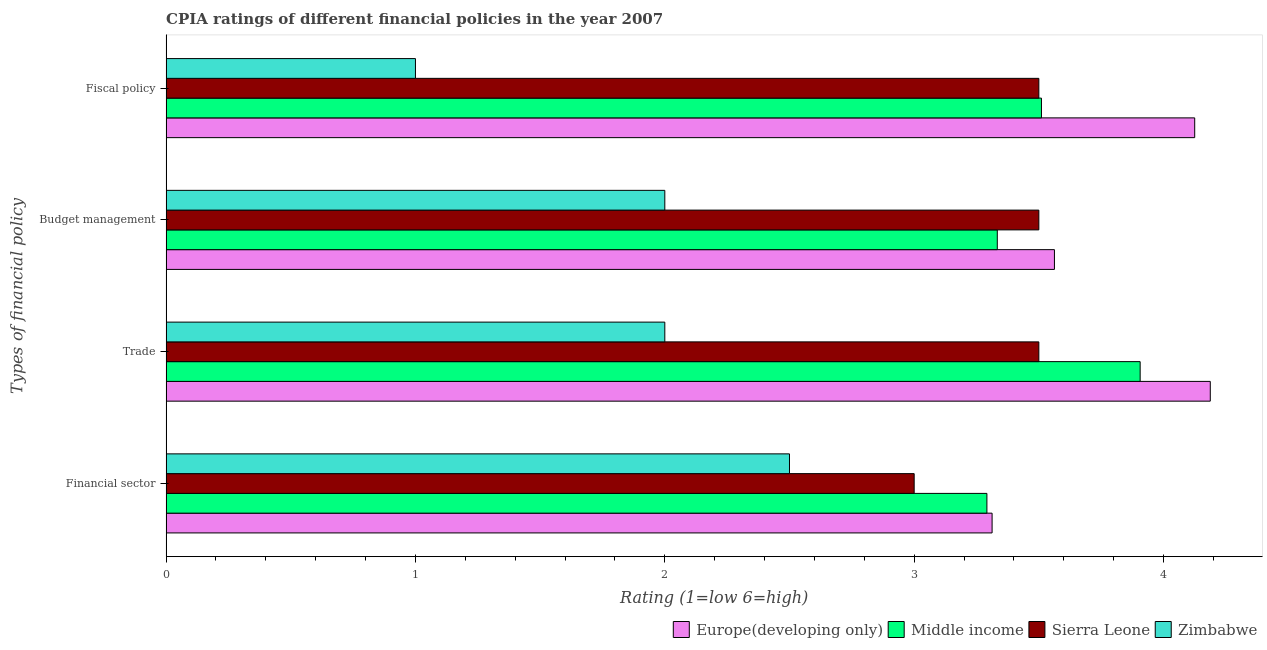Are the number of bars per tick equal to the number of legend labels?
Offer a very short reply. Yes. Are the number of bars on each tick of the Y-axis equal?
Your answer should be very brief. Yes. How many bars are there on the 3rd tick from the top?
Ensure brevity in your answer.  4. What is the label of the 3rd group of bars from the top?
Give a very brief answer. Trade. What is the cpia rating of financial sector in Sierra Leone?
Your answer should be compact. 3. Across all countries, what is the maximum cpia rating of budget management?
Provide a short and direct response. 3.56. In which country was the cpia rating of financial sector maximum?
Keep it short and to the point. Europe(developing only). In which country was the cpia rating of financial sector minimum?
Keep it short and to the point. Zimbabwe. What is the total cpia rating of trade in the graph?
Provide a succinct answer. 13.59. What is the difference between the cpia rating of trade in Europe(developing only) and that in Sierra Leone?
Provide a short and direct response. 0.69. What is the difference between the cpia rating of trade in Sierra Leone and the cpia rating of financial sector in Europe(developing only)?
Offer a very short reply. 0.19. What is the average cpia rating of budget management per country?
Your answer should be very brief. 3.1. What is the ratio of the cpia rating of budget management in Zimbabwe to that in Europe(developing only)?
Keep it short and to the point. 0.56. Is the cpia rating of fiscal policy in Middle income less than that in Zimbabwe?
Your answer should be very brief. No. What is the difference between the highest and the second highest cpia rating of financial sector?
Provide a short and direct response. 0.02. What is the difference between the highest and the lowest cpia rating of financial sector?
Offer a terse response. 0.81. In how many countries, is the cpia rating of financial sector greater than the average cpia rating of financial sector taken over all countries?
Keep it short and to the point. 2. Is the sum of the cpia rating of trade in Middle income and Europe(developing only) greater than the maximum cpia rating of financial sector across all countries?
Give a very brief answer. Yes. Is it the case that in every country, the sum of the cpia rating of fiscal policy and cpia rating of trade is greater than the sum of cpia rating of budget management and cpia rating of financial sector?
Your response must be concise. No. What does the 1st bar from the top in Fiscal policy represents?
Keep it short and to the point. Zimbabwe. What does the 2nd bar from the bottom in Fiscal policy represents?
Your answer should be compact. Middle income. Is it the case that in every country, the sum of the cpia rating of financial sector and cpia rating of trade is greater than the cpia rating of budget management?
Provide a short and direct response. Yes. Are all the bars in the graph horizontal?
Ensure brevity in your answer.  Yes. How many countries are there in the graph?
Offer a terse response. 4. What is the difference between two consecutive major ticks on the X-axis?
Your answer should be compact. 1. Does the graph contain any zero values?
Your answer should be very brief. No. How many legend labels are there?
Give a very brief answer. 4. How are the legend labels stacked?
Provide a short and direct response. Horizontal. What is the title of the graph?
Your answer should be very brief. CPIA ratings of different financial policies in the year 2007. What is the label or title of the X-axis?
Keep it short and to the point. Rating (1=low 6=high). What is the label or title of the Y-axis?
Provide a succinct answer. Types of financial policy. What is the Rating (1=low 6=high) of Europe(developing only) in Financial sector?
Give a very brief answer. 3.31. What is the Rating (1=low 6=high) in Middle income in Financial sector?
Your answer should be compact. 3.29. What is the Rating (1=low 6=high) in Europe(developing only) in Trade?
Give a very brief answer. 4.19. What is the Rating (1=low 6=high) of Middle income in Trade?
Offer a terse response. 3.91. What is the Rating (1=low 6=high) in Sierra Leone in Trade?
Your answer should be very brief. 3.5. What is the Rating (1=low 6=high) in Zimbabwe in Trade?
Your answer should be very brief. 2. What is the Rating (1=low 6=high) in Europe(developing only) in Budget management?
Provide a short and direct response. 3.56. What is the Rating (1=low 6=high) in Middle income in Budget management?
Keep it short and to the point. 3.33. What is the Rating (1=low 6=high) in Zimbabwe in Budget management?
Give a very brief answer. 2. What is the Rating (1=low 6=high) in Europe(developing only) in Fiscal policy?
Offer a terse response. 4.12. What is the Rating (1=low 6=high) in Middle income in Fiscal policy?
Keep it short and to the point. 3.51. What is the Rating (1=low 6=high) in Sierra Leone in Fiscal policy?
Give a very brief answer. 3.5. Across all Types of financial policy, what is the maximum Rating (1=low 6=high) in Europe(developing only)?
Your response must be concise. 4.19. Across all Types of financial policy, what is the maximum Rating (1=low 6=high) of Middle income?
Your answer should be very brief. 3.91. Across all Types of financial policy, what is the maximum Rating (1=low 6=high) of Sierra Leone?
Your answer should be compact. 3.5. Across all Types of financial policy, what is the maximum Rating (1=low 6=high) in Zimbabwe?
Your response must be concise. 2.5. Across all Types of financial policy, what is the minimum Rating (1=low 6=high) of Europe(developing only)?
Keep it short and to the point. 3.31. Across all Types of financial policy, what is the minimum Rating (1=low 6=high) of Middle income?
Offer a terse response. 3.29. What is the total Rating (1=low 6=high) in Europe(developing only) in the graph?
Provide a succinct answer. 15.19. What is the total Rating (1=low 6=high) of Middle income in the graph?
Offer a terse response. 14.04. What is the total Rating (1=low 6=high) in Sierra Leone in the graph?
Provide a short and direct response. 13.5. What is the difference between the Rating (1=low 6=high) in Europe(developing only) in Financial sector and that in Trade?
Your response must be concise. -0.88. What is the difference between the Rating (1=low 6=high) in Middle income in Financial sector and that in Trade?
Provide a succinct answer. -0.61. What is the difference between the Rating (1=low 6=high) in Zimbabwe in Financial sector and that in Trade?
Offer a very short reply. 0.5. What is the difference between the Rating (1=low 6=high) of Middle income in Financial sector and that in Budget management?
Ensure brevity in your answer.  -0.04. What is the difference between the Rating (1=low 6=high) of Sierra Leone in Financial sector and that in Budget management?
Make the answer very short. -0.5. What is the difference between the Rating (1=low 6=high) of Europe(developing only) in Financial sector and that in Fiscal policy?
Your response must be concise. -0.81. What is the difference between the Rating (1=low 6=high) in Middle income in Financial sector and that in Fiscal policy?
Your response must be concise. -0.22. What is the difference between the Rating (1=low 6=high) of Zimbabwe in Financial sector and that in Fiscal policy?
Give a very brief answer. 1.5. What is the difference between the Rating (1=low 6=high) in Middle income in Trade and that in Budget management?
Keep it short and to the point. 0.57. What is the difference between the Rating (1=low 6=high) of Europe(developing only) in Trade and that in Fiscal policy?
Your response must be concise. 0.06. What is the difference between the Rating (1=low 6=high) of Middle income in Trade and that in Fiscal policy?
Give a very brief answer. 0.4. What is the difference between the Rating (1=low 6=high) in Europe(developing only) in Budget management and that in Fiscal policy?
Offer a very short reply. -0.56. What is the difference between the Rating (1=low 6=high) of Middle income in Budget management and that in Fiscal policy?
Offer a very short reply. -0.18. What is the difference between the Rating (1=low 6=high) in Sierra Leone in Budget management and that in Fiscal policy?
Your answer should be compact. 0. What is the difference between the Rating (1=low 6=high) in Europe(developing only) in Financial sector and the Rating (1=low 6=high) in Middle income in Trade?
Your answer should be very brief. -0.59. What is the difference between the Rating (1=low 6=high) in Europe(developing only) in Financial sector and the Rating (1=low 6=high) in Sierra Leone in Trade?
Provide a short and direct response. -0.19. What is the difference between the Rating (1=low 6=high) of Europe(developing only) in Financial sector and the Rating (1=low 6=high) of Zimbabwe in Trade?
Provide a succinct answer. 1.31. What is the difference between the Rating (1=low 6=high) in Middle income in Financial sector and the Rating (1=low 6=high) in Sierra Leone in Trade?
Ensure brevity in your answer.  -0.21. What is the difference between the Rating (1=low 6=high) in Middle income in Financial sector and the Rating (1=low 6=high) in Zimbabwe in Trade?
Make the answer very short. 1.29. What is the difference between the Rating (1=low 6=high) in Sierra Leone in Financial sector and the Rating (1=low 6=high) in Zimbabwe in Trade?
Your answer should be compact. 1. What is the difference between the Rating (1=low 6=high) in Europe(developing only) in Financial sector and the Rating (1=low 6=high) in Middle income in Budget management?
Keep it short and to the point. -0.02. What is the difference between the Rating (1=low 6=high) in Europe(developing only) in Financial sector and the Rating (1=low 6=high) in Sierra Leone in Budget management?
Give a very brief answer. -0.19. What is the difference between the Rating (1=low 6=high) in Europe(developing only) in Financial sector and the Rating (1=low 6=high) in Zimbabwe in Budget management?
Your answer should be very brief. 1.31. What is the difference between the Rating (1=low 6=high) of Middle income in Financial sector and the Rating (1=low 6=high) of Sierra Leone in Budget management?
Offer a terse response. -0.21. What is the difference between the Rating (1=low 6=high) in Middle income in Financial sector and the Rating (1=low 6=high) in Zimbabwe in Budget management?
Ensure brevity in your answer.  1.29. What is the difference between the Rating (1=low 6=high) in Europe(developing only) in Financial sector and the Rating (1=low 6=high) in Middle income in Fiscal policy?
Keep it short and to the point. -0.2. What is the difference between the Rating (1=low 6=high) of Europe(developing only) in Financial sector and the Rating (1=low 6=high) of Sierra Leone in Fiscal policy?
Give a very brief answer. -0.19. What is the difference between the Rating (1=low 6=high) of Europe(developing only) in Financial sector and the Rating (1=low 6=high) of Zimbabwe in Fiscal policy?
Your answer should be very brief. 2.31. What is the difference between the Rating (1=low 6=high) in Middle income in Financial sector and the Rating (1=low 6=high) in Sierra Leone in Fiscal policy?
Give a very brief answer. -0.21. What is the difference between the Rating (1=low 6=high) of Middle income in Financial sector and the Rating (1=low 6=high) of Zimbabwe in Fiscal policy?
Make the answer very short. 2.29. What is the difference between the Rating (1=low 6=high) in Europe(developing only) in Trade and the Rating (1=low 6=high) in Middle income in Budget management?
Make the answer very short. 0.85. What is the difference between the Rating (1=low 6=high) in Europe(developing only) in Trade and the Rating (1=low 6=high) in Sierra Leone in Budget management?
Your answer should be compact. 0.69. What is the difference between the Rating (1=low 6=high) of Europe(developing only) in Trade and the Rating (1=low 6=high) of Zimbabwe in Budget management?
Your response must be concise. 2.19. What is the difference between the Rating (1=low 6=high) in Middle income in Trade and the Rating (1=low 6=high) in Sierra Leone in Budget management?
Your response must be concise. 0.41. What is the difference between the Rating (1=low 6=high) of Middle income in Trade and the Rating (1=low 6=high) of Zimbabwe in Budget management?
Offer a terse response. 1.91. What is the difference between the Rating (1=low 6=high) of Europe(developing only) in Trade and the Rating (1=low 6=high) of Middle income in Fiscal policy?
Your answer should be compact. 0.68. What is the difference between the Rating (1=low 6=high) in Europe(developing only) in Trade and the Rating (1=low 6=high) in Sierra Leone in Fiscal policy?
Your answer should be compact. 0.69. What is the difference between the Rating (1=low 6=high) of Europe(developing only) in Trade and the Rating (1=low 6=high) of Zimbabwe in Fiscal policy?
Your answer should be very brief. 3.19. What is the difference between the Rating (1=low 6=high) of Middle income in Trade and the Rating (1=low 6=high) of Sierra Leone in Fiscal policy?
Offer a very short reply. 0.41. What is the difference between the Rating (1=low 6=high) of Middle income in Trade and the Rating (1=low 6=high) of Zimbabwe in Fiscal policy?
Ensure brevity in your answer.  2.91. What is the difference between the Rating (1=low 6=high) in Sierra Leone in Trade and the Rating (1=low 6=high) in Zimbabwe in Fiscal policy?
Provide a short and direct response. 2.5. What is the difference between the Rating (1=low 6=high) of Europe(developing only) in Budget management and the Rating (1=low 6=high) of Middle income in Fiscal policy?
Your response must be concise. 0.05. What is the difference between the Rating (1=low 6=high) in Europe(developing only) in Budget management and the Rating (1=low 6=high) in Sierra Leone in Fiscal policy?
Give a very brief answer. 0.06. What is the difference between the Rating (1=low 6=high) in Europe(developing only) in Budget management and the Rating (1=low 6=high) in Zimbabwe in Fiscal policy?
Your answer should be very brief. 2.56. What is the difference between the Rating (1=low 6=high) in Middle income in Budget management and the Rating (1=low 6=high) in Zimbabwe in Fiscal policy?
Your response must be concise. 2.33. What is the difference between the Rating (1=low 6=high) of Sierra Leone in Budget management and the Rating (1=low 6=high) of Zimbabwe in Fiscal policy?
Provide a succinct answer. 2.5. What is the average Rating (1=low 6=high) in Europe(developing only) per Types of financial policy?
Ensure brevity in your answer.  3.8. What is the average Rating (1=low 6=high) of Middle income per Types of financial policy?
Provide a succinct answer. 3.51. What is the average Rating (1=low 6=high) in Sierra Leone per Types of financial policy?
Make the answer very short. 3.38. What is the average Rating (1=low 6=high) in Zimbabwe per Types of financial policy?
Provide a short and direct response. 1.88. What is the difference between the Rating (1=low 6=high) in Europe(developing only) and Rating (1=low 6=high) in Middle income in Financial sector?
Your response must be concise. 0.02. What is the difference between the Rating (1=low 6=high) of Europe(developing only) and Rating (1=low 6=high) of Sierra Leone in Financial sector?
Offer a very short reply. 0.31. What is the difference between the Rating (1=low 6=high) in Europe(developing only) and Rating (1=low 6=high) in Zimbabwe in Financial sector?
Give a very brief answer. 0.81. What is the difference between the Rating (1=low 6=high) in Middle income and Rating (1=low 6=high) in Sierra Leone in Financial sector?
Keep it short and to the point. 0.29. What is the difference between the Rating (1=low 6=high) in Middle income and Rating (1=low 6=high) in Zimbabwe in Financial sector?
Make the answer very short. 0.79. What is the difference between the Rating (1=low 6=high) in Sierra Leone and Rating (1=low 6=high) in Zimbabwe in Financial sector?
Provide a short and direct response. 0.5. What is the difference between the Rating (1=low 6=high) in Europe(developing only) and Rating (1=low 6=high) in Middle income in Trade?
Provide a short and direct response. 0.28. What is the difference between the Rating (1=low 6=high) in Europe(developing only) and Rating (1=low 6=high) in Sierra Leone in Trade?
Ensure brevity in your answer.  0.69. What is the difference between the Rating (1=low 6=high) in Europe(developing only) and Rating (1=low 6=high) in Zimbabwe in Trade?
Provide a short and direct response. 2.19. What is the difference between the Rating (1=low 6=high) in Middle income and Rating (1=low 6=high) in Sierra Leone in Trade?
Give a very brief answer. 0.41. What is the difference between the Rating (1=low 6=high) of Middle income and Rating (1=low 6=high) of Zimbabwe in Trade?
Give a very brief answer. 1.91. What is the difference between the Rating (1=low 6=high) in Europe(developing only) and Rating (1=low 6=high) in Middle income in Budget management?
Your answer should be very brief. 0.23. What is the difference between the Rating (1=low 6=high) in Europe(developing only) and Rating (1=low 6=high) in Sierra Leone in Budget management?
Keep it short and to the point. 0.06. What is the difference between the Rating (1=low 6=high) of Europe(developing only) and Rating (1=low 6=high) of Zimbabwe in Budget management?
Keep it short and to the point. 1.56. What is the difference between the Rating (1=low 6=high) of Middle income and Rating (1=low 6=high) of Zimbabwe in Budget management?
Your answer should be compact. 1.33. What is the difference between the Rating (1=low 6=high) in Europe(developing only) and Rating (1=low 6=high) in Middle income in Fiscal policy?
Give a very brief answer. 0.61. What is the difference between the Rating (1=low 6=high) of Europe(developing only) and Rating (1=low 6=high) of Zimbabwe in Fiscal policy?
Offer a very short reply. 3.12. What is the difference between the Rating (1=low 6=high) of Middle income and Rating (1=low 6=high) of Sierra Leone in Fiscal policy?
Make the answer very short. 0.01. What is the difference between the Rating (1=low 6=high) of Middle income and Rating (1=low 6=high) of Zimbabwe in Fiscal policy?
Provide a succinct answer. 2.51. What is the difference between the Rating (1=low 6=high) of Sierra Leone and Rating (1=low 6=high) of Zimbabwe in Fiscal policy?
Offer a terse response. 2.5. What is the ratio of the Rating (1=low 6=high) in Europe(developing only) in Financial sector to that in Trade?
Offer a very short reply. 0.79. What is the ratio of the Rating (1=low 6=high) of Middle income in Financial sector to that in Trade?
Provide a short and direct response. 0.84. What is the ratio of the Rating (1=low 6=high) in Sierra Leone in Financial sector to that in Trade?
Your response must be concise. 0.86. What is the ratio of the Rating (1=low 6=high) of Zimbabwe in Financial sector to that in Trade?
Make the answer very short. 1.25. What is the ratio of the Rating (1=low 6=high) in Europe(developing only) in Financial sector to that in Budget management?
Your answer should be compact. 0.93. What is the ratio of the Rating (1=low 6=high) of Middle income in Financial sector to that in Budget management?
Provide a short and direct response. 0.99. What is the ratio of the Rating (1=low 6=high) in Sierra Leone in Financial sector to that in Budget management?
Your answer should be compact. 0.86. What is the ratio of the Rating (1=low 6=high) in Europe(developing only) in Financial sector to that in Fiscal policy?
Provide a succinct answer. 0.8. What is the ratio of the Rating (1=low 6=high) in Middle income in Financial sector to that in Fiscal policy?
Provide a short and direct response. 0.94. What is the ratio of the Rating (1=low 6=high) of Europe(developing only) in Trade to that in Budget management?
Ensure brevity in your answer.  1.18. What is the ratio of the Rating (1=low 6=high) of Middle income in Trade to that in Budget management?
Give a very brief answer. 1.17. What is the ratio of the Rating (1=low 6=high) in Sierra Leone in Trade to that in Budget management?
Provide a short and direct response. 1. What is the ratio of the Rating (1=low 6=high) in Europe(developing only) in Trade to that in Fiscal policy?
Offer a terse response. 1.02. What is the ratio of the Rating (1=low 6=high) in Middle income in Trade to that in Fiscal policy?
Keep it short and to the point. 1.11. What is the ratio of the Rating (1=low 6=high) of Sierra Leone in Trade to that in Fiscal policy?
Provide a succinct answer. 1. What is the ratio of the Rating (1=low 6=high) of Zimbabwe in Trade to that in Fiscal policy?
Provide a succinct answer. 2. What is the ratio of the Rating (1=low 6=high) in Europe(developing only) in Budget management to that in Fiscal policy?
Offer a very short reply. 0.86. What is the ratio of the Rating (1=low 6=high) in Middle income in Budget management to that in Fiscal policy?
Offer a very short reply. 0.95. What is the ratio of the Rating (1=low 6=high) of Zimbabwe in Budget management to that in Fiscal policy?
Your answer should be very brief. 2. What is the difference between the highest and the second highest Rating (1=low 6=high) of Europe(developing only)?
Provide a succinct answer. 0.06. What is the difference between the highest and the second highest Rating (1=low 6=high) of Middle income?
Give a very brief answer. 0.4. What is the difference between the highest and the second highest Rating (1=low 6=high) of Sierra Leone?
Give a very brief answer. 0. What is the difference between the highest and the lowest Rating (1=low 6=high) in Middle income?
Provide a short and direct response. 0.61. What is the difference between the highest and the lowest Rating (1=low 6=high) in Zimbabwe?
Offer a terse response. 1.5. 